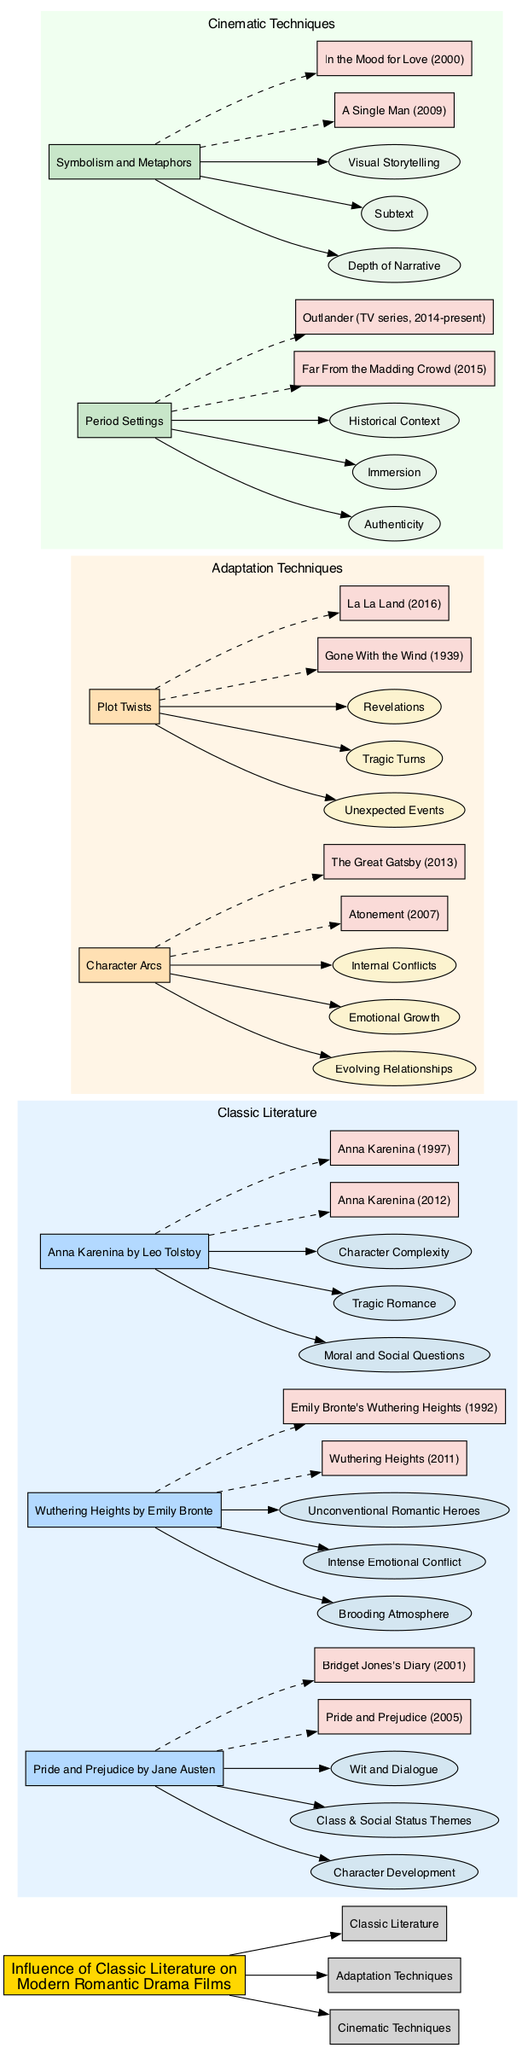What is the modern film adaptation of "Pride and Prejudice" listed in the diagram? The diagram includes "Pride and Prejudice (2005)" and "Bridget Jones's Diary (2001)" as modern film adaptations. The first adaptation is specifically linked to "Pride and Prejudice."
Answer: Pride and Prejudice (2005) How many influences are attributed to "Anna Karenina"? The diagram shows three influences listed under "Anna Karenina," which are "Moral and Social Questions," "Tragic Romance," and "Character Complexity."
Answer: 3 Which adaptation technique has the case study "Atonement"? The node "Atonement" is connected to the "Character Arcs" node, indicating it is included in that adaptation technique's case studies.
Answer: Character Arcs What is the main theme influence of "Wuthering Heights"? Among the influences listed under "Wuthering Heights," the dramatic themes include "Brooding Atmosphere," "Intense Emotional Conflict," and "Unconventional Romantic Heroes." The first influence, "Brooding Atmosphere," is a clear and defining theme of the work.
Answer: Brooding Atmosphere What cinematic technique is associated with "Authenticity"? In the diagram, "Authenticity" is listed as an important aspect under the node "Period Settings," which indicates its influence in cinematic representations of classic literature adaptations.
Answer: Period Settings What do "Tragic Turns" refer to in the adaptation techniques? "Tragic Turns" is a listed usage of the "Plot Twists" adaptation technique, indicating specific narrative elements derived from classic literature that modern films often employ.
Answer: Plot Twists Which classic literature book influences "Unconventional Romantic Heroes"? The influence "Unconventional Romantic Heroes" directly connects to "Wuthering Heights" by Emily Bronte, indicating the thematic depth linking the book and its adaptations.
Answer: Wuthering Heights How many movies are linked to "Cinematic Techniques"? The diagram contains two groups of examples linked to "Cinematic Techniques" based on distinctive techniques identified; there are four unique films listed across the various techniques.
Answer: 4 